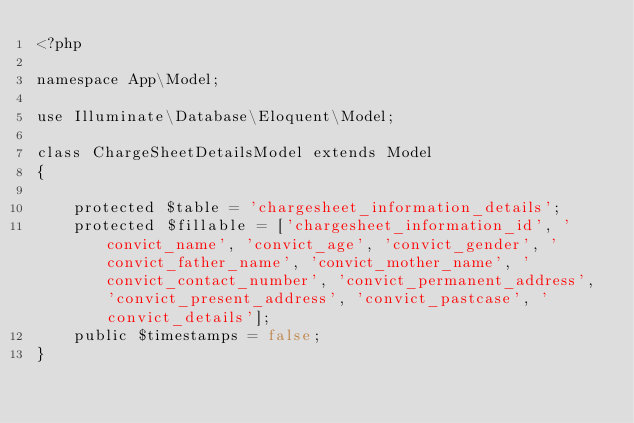<code> <loc_0><loc_0><loc_500><loc_500><_PHP_><?php

namespace App\Model;

use Illuminate\Database\Eloquent\Model;

class ChargeSheetDetailsModel extends Model
{
    
    protected $table = 'chargesheet_information_details';
    protected $fillable = ['chargesheet_information_id', 'convict_name', 'convict_age', 'convict_gender', 'convict_father_name', 'convict_mother_name', 'convict_contact_number', 'convict_permanent_address', 'convict_present_address', 'convict_pastcase', 'convict_details'];
    public $timestamps = false;
}
</code> 